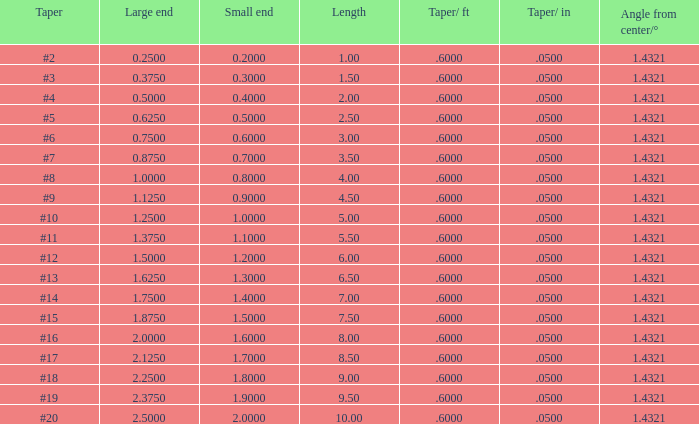Identify the taper/ft with a taper of #2 and a large end smaller than 0.5. 0.6. 